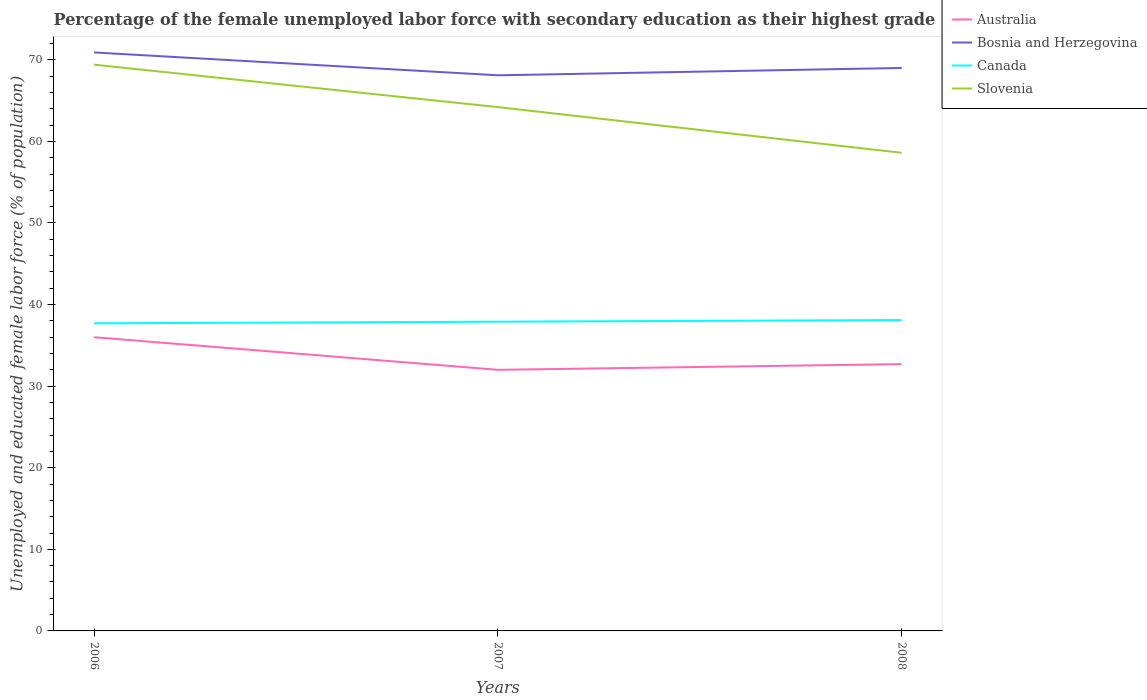How many different coloured lines are there?
Your answer should be very brief. 4. Does the line corresponding to Canada intersect with the line corresponding to Bosnia and Herzegovina?
Make the answer very short. No. Across all years, what is the maximum percentage of the unemployed female labor force with secondary education in Canada?
Make the answer very short. 37.7. What is the total percentage of the unemployed female labor force with secondary education in Australia in the graph?
Offer a terse response. -0.7. What is the difference between the highest and the second highest percentage of the unemployed female labor force with secondary education in Slovenia?
Keep it short and to the point. 10.8. How many lines are there?
Provide a short and direct response. 4. Are the values on the major ticks of Y-axis written in scientific E-notation?
Give a very brief answer. No. Does the graph contain grids?
Offer a terse response. No. How many legend labels are there?
Offer a terse response. 4. How are the legend labels stacked?
Make the answer very short. Vertical. What is the title of the graph?
Offer a very short reply. Percentage of the female unemployed labor force with secondary education as their highest grade. What is the label or title of the X-axis?
Provide a succinct answer. Years. What is the label or title of the Y-axis?
Keep it short and to the point. Unemployed and educated female labor force (% of population). What is the Unemployed and educated female labor force (% of population) of Bosnia and Herzegovina in 2006?
Provide a short and direct response. 70.9. What is the Unemployed and educated female labor force (% of population) in Canada in 2006?
Provide a succinct answer. 37.7. What is the Unemployed and educated female labor force (% of population) in Slovenia in 2006?
Offer a terse response. 69.4. What is the Unemployed and educated female labor force (% of population) of Bosnia and Herzegovina in 2007?
Keep it short and to the point. 68.1. What is the Unemployed and educated female labor force (% of population) in Canada in 2007?
Keep it short and to the point. 37.9. What is the Unemployed and educated female labor force (% of population) in Slovenia in 2007?
Your response must be concise. 64.2. What is the Unemployed and educated female labor force (% of population) in Australia in 2008?
Your answer should be compact. 32.7. What is the Unemployed and educated female labor force (% of population) in Canada in 2008?
Give a very brief answer. 38.1. What is the Unemployed and educated female labor force (% of population) of Slovenia in 2008?
Make the answer very short. 58.6. Across all years, what is the maximum Unemployed and educated female labor force (% of population) in Australia?
Keep it short and to the point. 36. Across all years, what is the maximum Unemployed and educated female labor force (% of population) of Bosnia and Herzegovina?
Give a very brief answer. 70.9. Across all years, what is the maximum Unemployed and educated female labor force (% of population) in Canada?
Your answer should be very brief. 38.1. Across all years, what is the maximum Unemployed and educated female labor force (% of population) in Slovenia?
Your response must be concise. 69.4. Across all years, what is the minimum Unemployed and educated female labor force (% of population) in Australia?
Provide a succinct answer. 32. Across all years, what is the minimum Unemployed and educated female labor force (% of population) of Bosnia and Herzegovina?
Give a very brief answer. 68.1. Across all years, what is the minimum Unemployed and educated female labor force (% of population) of Canada?
Offer a very short reply. 37.7. Across all years, what is the minimum Unemployed and educated female labor force (% of population) in Slovenia?
Offer a very short reply. 58.6. What is the total Unemployed and educated female labor force (% of population) of Australia in the graph?
Give a very brief answer. 100.7. What is the total Unemployed and educated female labor force (% of population) of Bosnia and Herzegovina in the graph?
Provide a short and direct response. 208. What is the total Unemployed and educated female labor force (% of population) in Canada in the graph?
Your answer should be compact. 113.7. What is the total Unemployed and educated female labor force (% of population) of Slovenia in the graph?
Give a very brief answer. 192.2. What is the difference between the Unemployed and educated female labor force (% of population) in Australia in 2006 and that in 2007?
Provide a short and direct response. 4. What is the difference between the Unemployed and educated female labor force (% of population) of Canada in 2006 and that in 2007?
Give a very brief answer. -0.2. What is the difference between the Unemployed and educated female labor force (% of population) in Slovenia in 2006 and that in 2007?
Your response must be concise. 5.2. What is the difference between the Unemployed and educated female labor force (% of population) in Bosnia and Herzegovina in 2006 and that in 2008?
Give a very brief answer. 1.9. What is the difference between the Unemployed and educated female labor force (% of population) of Australia in 2006 and the Unemployed and educated female labor force (% of population) of Bosnia and Herzegovina in 2007?
Provide a short and direct response. -32.1. What is the difference between the Unemployed and educated female labor force (% of population) in Australia in 2006 and the Unemployed and educated female labor force (% of population) in Canada in 2007?
Your answer should be very brief. -1.9. What is the difference between the Unemployed and educated female labor force (% of population) in Australia in 2006 and the Unemployed and educated female labor force (% of population) in Slovenia in 2007?
Offer a terse response. -28.2. What is the difference between the Unemployed and educated female labor force (% of population) in Bosnia and Herzegovina in 2006 and the Unemployed and educated female labor force (% of population) in Canada in 2007?
Your response must be concise. 33. What is the difference between the Unemployed and educated female labor force (% of population) in Bosnia and Herzegovina in 2006 and the Unemployed and educated female labor force (% of population) in Slovenia in 2007?
Ensure brevity in your answer.  6.7. What is the difference between the Unemployed and educated female labor force (% of population) of Canada in 2006 and the Unemployed and educated female labor force (% of population) of Slovenia in 2007?
Give a very brief answer. -26.5. What is the difference between the Unemployed and educated female labor force (% of population) of Australia in 2006 and the Unemployed and educated female labor force (% of population) of Bosnia and Herzegovina in 2008?
Offer a very short reply. -33. What is the difference between the Unemployed and educated female labor force (% of population) in Australia in 2006 and the Unemployed and educated female labor force (% of population) in Slovenia in 2008?
Your answer should be very brief. -22.6. What is the difference between the Unemployed and educated female labor force (% of population) in Bosnia and Herzegovina in 2006 and the Unemployed and educated female labor force (% of population) in Canada in 2008?
Give a very brief answer. 32.8. What is the difference between the Unemployed and educated female labor force (% of population) in Bosnia and Herzegovina in 2006 and the Unemployed and educated female labor force (% of population) in Slovenia in 2008?
Give a very brief answer. 12.3. What is the difference between the Unemployed and educated female labor force (% of population) of Canada in 2006 and the Unemployed and educated female labor force (% of population) of Slovenia in 2008?
Your answer should be very brief. -20.9. What is the difference between the Unemployed and educated female labor force (% of population) in Australia in 2007 and the Unemployed and educated female labor force (% of population) in Bosnia and Herzegovina in 2008?
Make the answer very short. -37. What is the difference between the Unemployed and educated female labor force (% of population) in Australia in 2007 and the Unemployed and educated female labor force (% of population) in Slovenia in 2008?
Offer a very short reply. -26.6. What is the difference between the Unemployed and educated female labor force (% of population) in Bosnia and Herzegovina in 2007 and the Unemployed and educated female labor force (% of population) in Slovenia in 2008?
Offer a terse response. 9.5. What is the difference between the Unemployed and educated female labor force (% of population) in Canada in 2007 and the Unemployed and educated female labor force (% of population) in Slovenia in 2008?
Make the answer very short. -20.7. What is the average Unemployed and educated female labor force (% of population) of Australia per year?
Keep it short and to the point. 33.57. What is the average Unemployed and educated female labor force (% of population) in Bosnia and Herzegovina per year?
Your answer should be compact. 69.33. What is the average Unemployed and educated female labor force (% of population) of Canada per year?
Your answer should be compact. 37.9. What is the average Unemployed and educated female labor force (% of population) of Slovenia per year?
Keep it short and to the point. 64.07. In the year 2006, what is the difference between the Unemployed and educated female labor force (% of population) in Australia and Unemployed and educated female labor force (% of population) in Bosnia and Herzegovina?
Provide a short and direct response. -34.9. In the year 2006, what is the difference between the Unemployed and educated female labor force (% of population) of Australia and Unemployed and educated female labor force (% of population) of Canada?
Your answer should be compact. -1.7. In the year 2006, what is the difference between the Unemployed and educated female labor force (% of population) in Australia and Unemployed and educated female labor force (% of population) in Slovenia?
Offer a terse response. -33.4. In the year 2006, what is the difference between the Unemployed and educated female labor force (% of population) in Bosnia and Herzegovina and Unemployed and educated female labor force (% of population) in Canada?
Keep it short and to the point. 33.2. In the year 2006, what is the difference between the Unemployed and educated female labor force (% of population) of Canada and Unemployed and educated female labor force (% of population) of Slovenia?
Make the answer very short. -31.7. In the year 2007, what is the difference between the Unemployed and educated female labor force (% of population) of Australia and Unemployed and educated female labor force (% of population) of Bosnia and Herzegovina?
Ensure brevity in your answer.  -36.1. In the year 2007, what is the difference between the Unemployed and educated female labor force (% of population) of Australia and Unemployed and educated female labor force (% of population) of Slovenia?
Your answer should be compact. -32.2. In the year 2007, what is the difference between the Unemployed and educated female labor force (% of population) of Bosnia and Herzegovina and Unemployed and educated female labor force (% of population) of Canada?
Offer a very short reply. 30.2. In the year 2007, what is the difference between the Unemployed and educated female labor force (% of population) of Bosnia and Herzegovina and Unemployed and educated female labor force (% of population) of Slovenia?
Your answer should be compact. 3.9. In the year 2007, what is the difference between the Unemployed and educated female labor force (% of population) in Canada and Unemployed and educated female labor force (% of population) in Slovenia?
Offer a terse response. -26.3. In the year 2008, what is the difference between the Unemployed and educated female labor force (% of population) in Australia and Unemployed and educated female labor force (% of population) in Bosnia and Herzegovina?
Keep it short and to the point. -36.3. In the year 2008, what is the difference between the Unemployed and educated female labor force (% of population) of Australia and Unemployed and educated female labor force (% of population) of Slovenia?
Offer a very short reply. -25.9. In the year 2008, what is the difference between the Unemployed and educated female labor force (% of population) in Bosnia and Herzegovina and Unemployed and educated female labor force (% of population) in Canada?
Offer a very short reply. 30.9. In the year 2008, what is the difference between the Unemployed and educated female labor force (% of population) of Bosnia and Herzegovina and Unemployed and educated female labor force (% of population) of Slovenia?
Provide a short and direct response. 10.4. In the year 2008, what is the difference between the Unemployed and educated female labor force (% of population) in Canada and Unemployed and educated female labor force (% of population) in Slovenia?
Your answer should be compact. -20.5. What is the ratio of the Unemployed and educated female labor force (% of population) of Australia in 2006 to that in 2007?
Your response must be concise. 1.12. What is the ratio of the Unemployed and educated female labor force (% of population) in Bosnia and Herzegovina in 2006 to that in 2007?
Your answer should be very brief. 1.04. What is the ratio of the Unemployed and educated female labor force (% of population) in Canada in 2006 to that in 2007?
Keep it short and to the point. 0.99. What is the ratio of the Unemployed and educated female labor force (% of population) in Slovenia in 2006 to that in 2007?
Your answer should be very brief. 1.08. What is the ratio of the Unemployed and educated female labor force (% of population) of Australia in 2006 to that in 2008?
Give a very brief answer. 1.1. What is the ratio of the Unemployed and educated female labor force (% of population) in Bosnia and Herzegovina in 2006 to that in 2008?
Your answer should be very brief. 1.03. What is the ratio of the Unemployed and educated female labor force (% of population) in Canada in 2006 to that in 2008?
Your answer should be very brief. 0.99. What is the ratio of the Unemployed and educated female labor force (% of population) of Slovenia in 2006 to that in 2008?
Ensure brevity in your answer.  1.18. What is the ratio of the Unemployed and educated female labor force (% of population) of Australia in 2007 to that in 2008?
Give a very brief answer. 0.98. What is the ratio of the Unemployed and educated female labor force (% of population) of Bosnia and Herzegovina in 2007 to that in 2008?
Offer a very short reply. 0.99. What is the ratio of the Unemployed and educated female labor force (% of population) in Canada in 2007 to that in 2008?
Your answer should be very brief. 0.99. What is the ratio of the Unemployed and educated female labor force (% of population) of Slovenia in 2007 to that in 2008?
Offer a terse response. 1.1. What is the difference between the highest and the lowest Unemployed and educated female labor force (% of population) of Australia?
Keep it short and to the point. 4. What is the difference between the highest and the lowest Unemployed and educated female labor force (% of population) of Canada?
Make the answer very short. 0.4. 